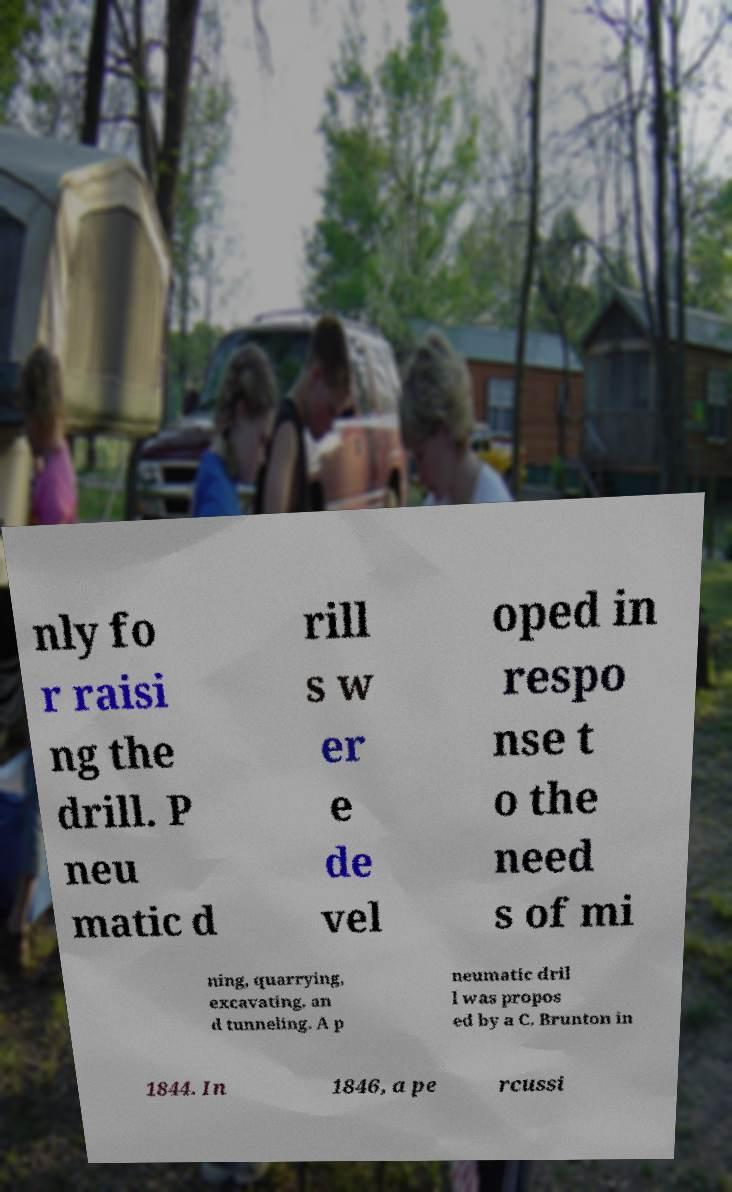What messages or text are displayed in this image? I need them in a readable, typed format. nly fo r raisi ng the drill. P neu matic d rill s w er e de vel oped in respo nse t o the need s of mi ning, quarrying, excavating, an d tunneling. A p neumatic dril l was propos ed by a C. Brunton in 1844. In 1846, a pe rcussi 